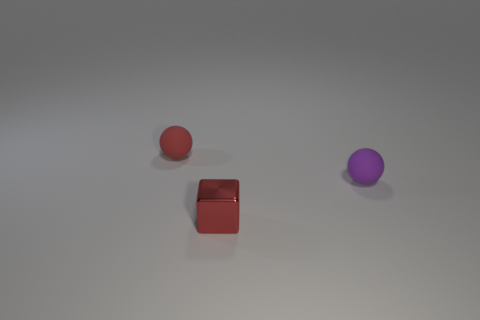Are there any other things that have the same shape as the tiny red shiny object?
Ensure brevity in your answer.  No. There is another matte thing that is the same shape as the purple matte thing; what is its color?
Your answer should be very brief. Red. There is a sphere left of the red metal thing; is it the same size as the red cube?
Make the answer very short. Yes. Are the tiny purple sphere and the sphere that is behind the tiny purple matte sphere made of the same material?
Ensure brevity in your answer.  Yes. Are there fewer red matte objects that are in front of the tiny purple rubber object than red things that are left of the cube?
Give a very brief answer. Yes. What is the color of the other small ball that is made of the same material as the tiny red ball?
Make the answer very short. Purple. There is a matte ball on the right side of the red matte object; is there a tiny matte sphere on the right side of it?
Your answer should be very brief. No. There is another rubber object that is the same size as the purple thing; what is its color?
Provide a succinct answer. Red. How many objects are big brown cylinders or small rubber balls?
Your response must be concise. 2. There is a red thing in front of the rubber ball in front of the small object that is behind the tiny purple rubber object; what is its size?
Your response must be concise. Small. 